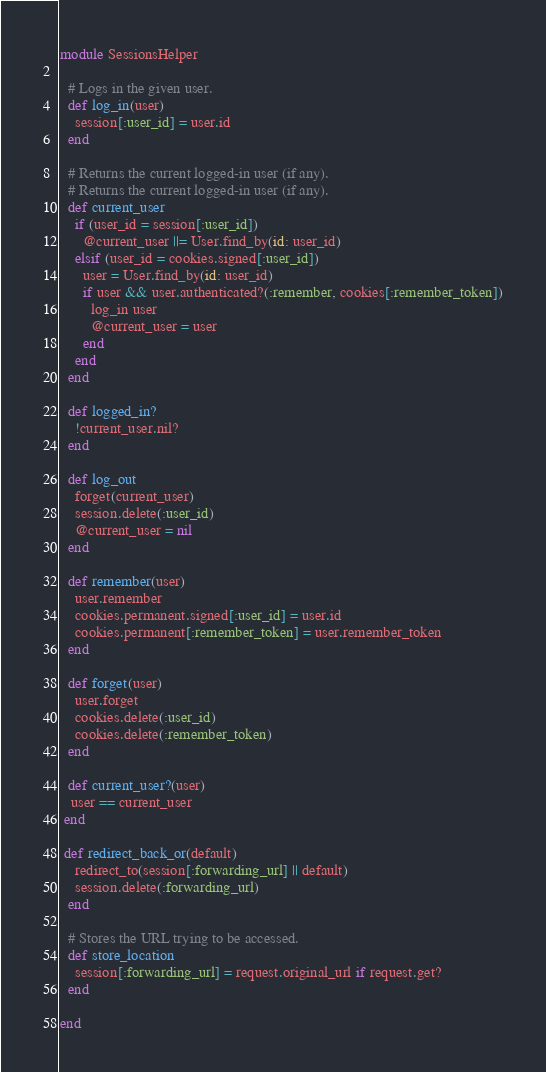Convert code to text. <code><loc_0><loc_0><loc_500><loc_500><_Ruby_>module SessionsHelper

  # Logs in the given user.
  def log_in(user)
    session[:user_id] = user.id
  end

  # Returns the current logged-in user (if any).
  # Returns the current logged-in user (if any).
  def current_user
    if (user_id = session[:user_id])
      @current_user ||= User.find_by(id: user_id)
    elsif (user_id = cookies.signed[:user_id])
      user = User.find_by(id: user_id)
      if user && user.authenticated?(:remember, cookies[:remember_token])
        log_in user
        @current_user = user
      end
    end
  end

  def logged_in?
    !current_user.nil?
  end

  def log_out
    forget(current_user)
    session.delete(:user_id)
    @current_user = nil
  end

  def remember(user)
    user.remember
    cookies.permanent.signed[:user_id] = user.id
    cookies.permanent[:remember_token] = user.remember_token
  end

  def forget(user)
    user.forget
    cookies.delete(:user_id)
    cookies.delete(:remember_token)
  end

  def current_user?(user)
   user == current_user
 end

 def redirect_back_or(default)
    redirect_to(session[:forwarding_url] || default)
    session.delete(:forwarding_url)
  end

  # Stores the URL trying to be accessed.
  def store_location
    session[:forwarding_url] = request.original_url if request.get?
  end

end
</code> 